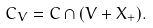Convert formula to latex. <formula><loc_0><loc_0><loc_500><loc_500>C _ { V } = C \cap ( V + X _ { + } ) .</formula> 